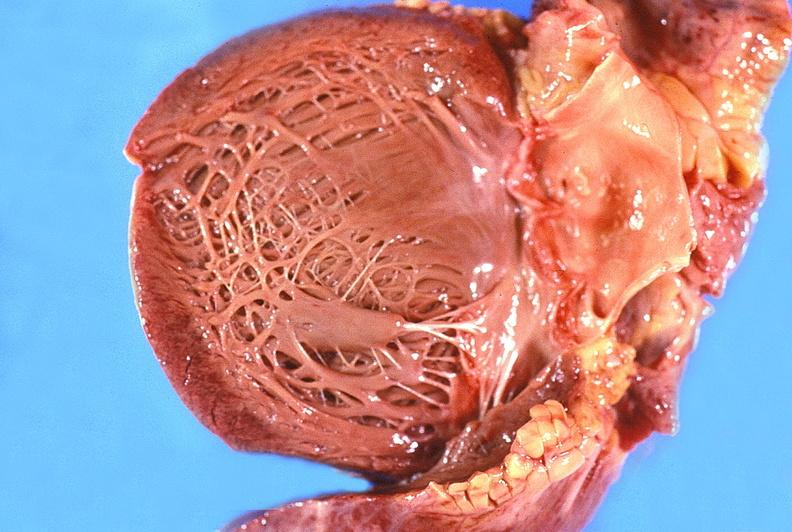does macerated stillborn show normal aortic valve?
Answer the question using a single word or phrase. No 